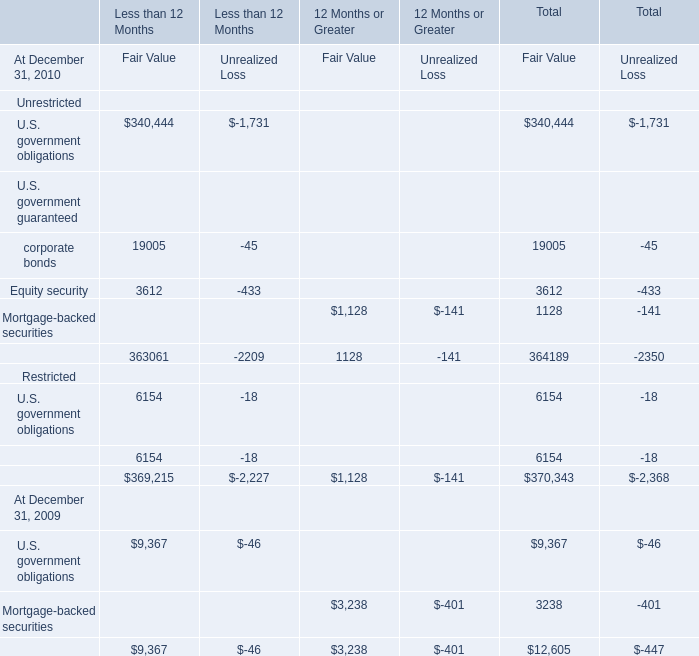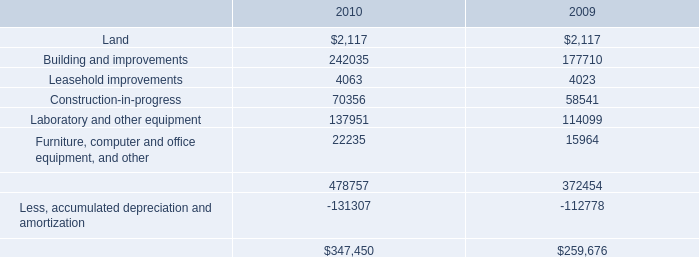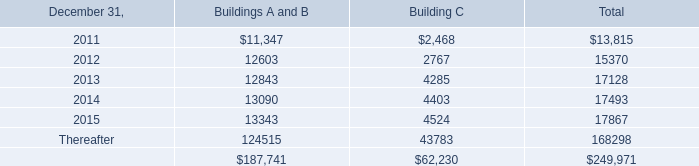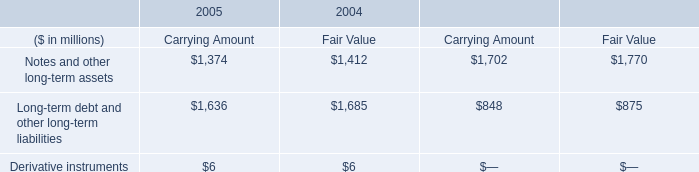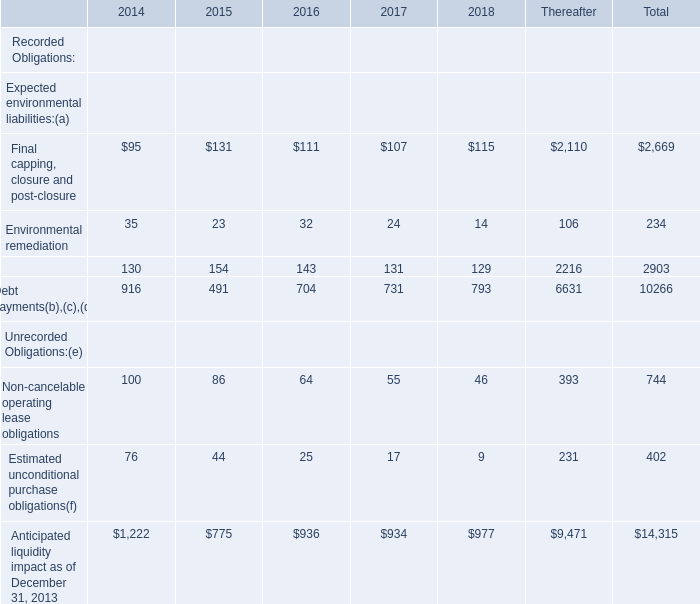What's the 50 % of the Fair Value in terms of Total for Unrestricted:Equity security at December 31, 2010? 
Computations: (0.5 * 3612)
Answer: 1806.0. 